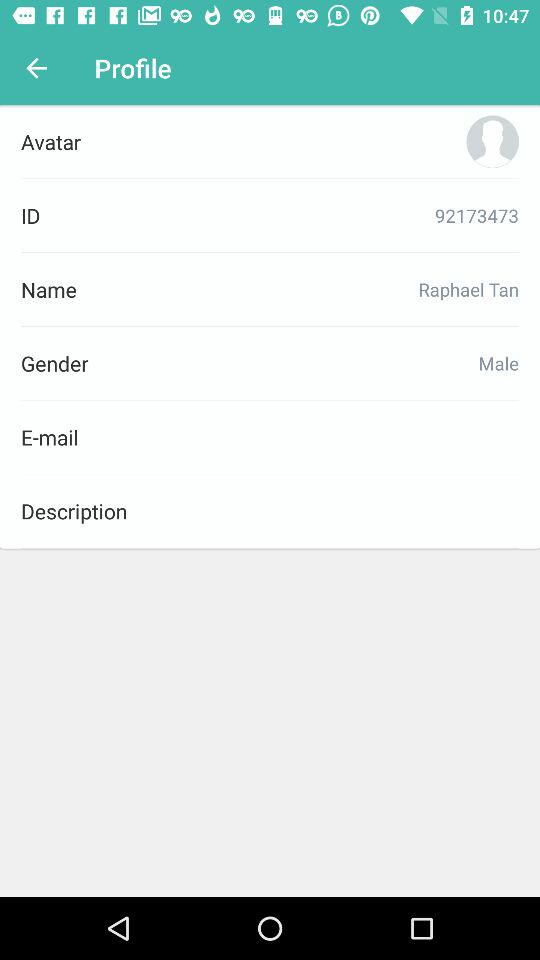What is the mentioned gender? The mentioned gender is male. 